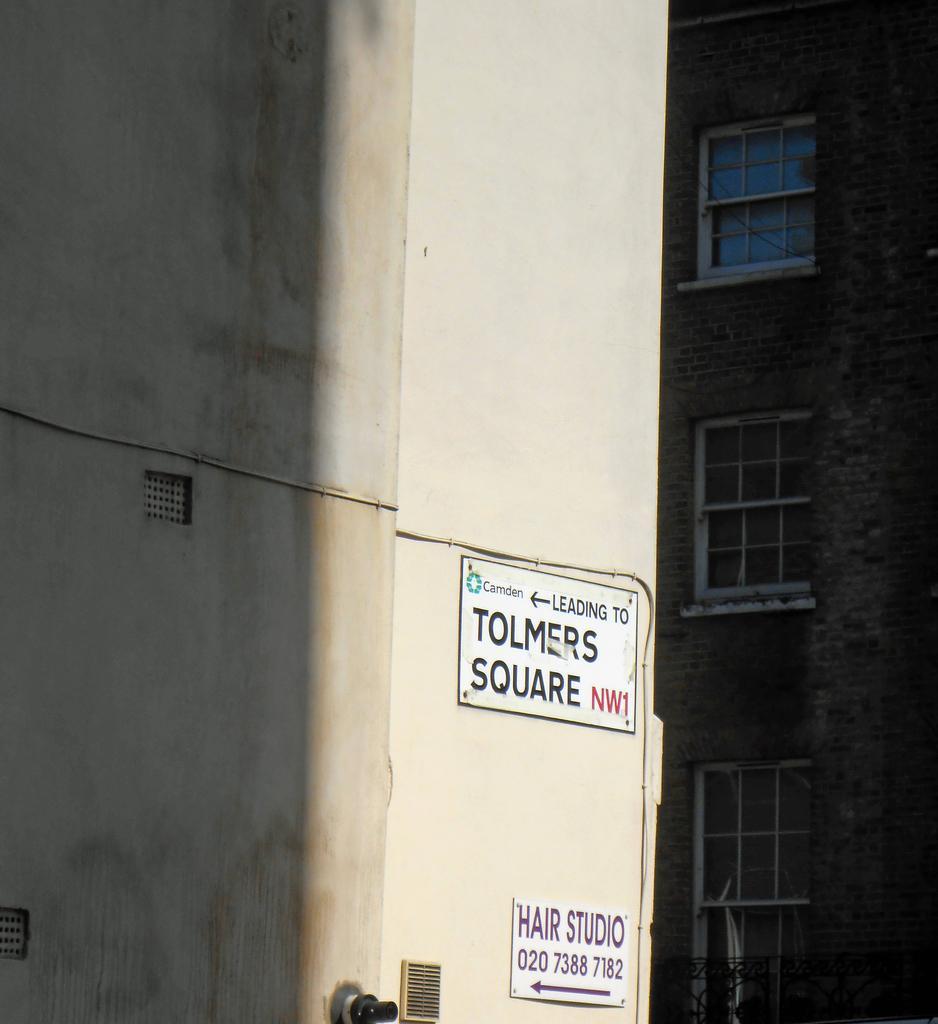How would you summarize this image in a sentence or two? In this image there are two boards with some text are attached to the wall of a building, in front of this building there is an another building. 